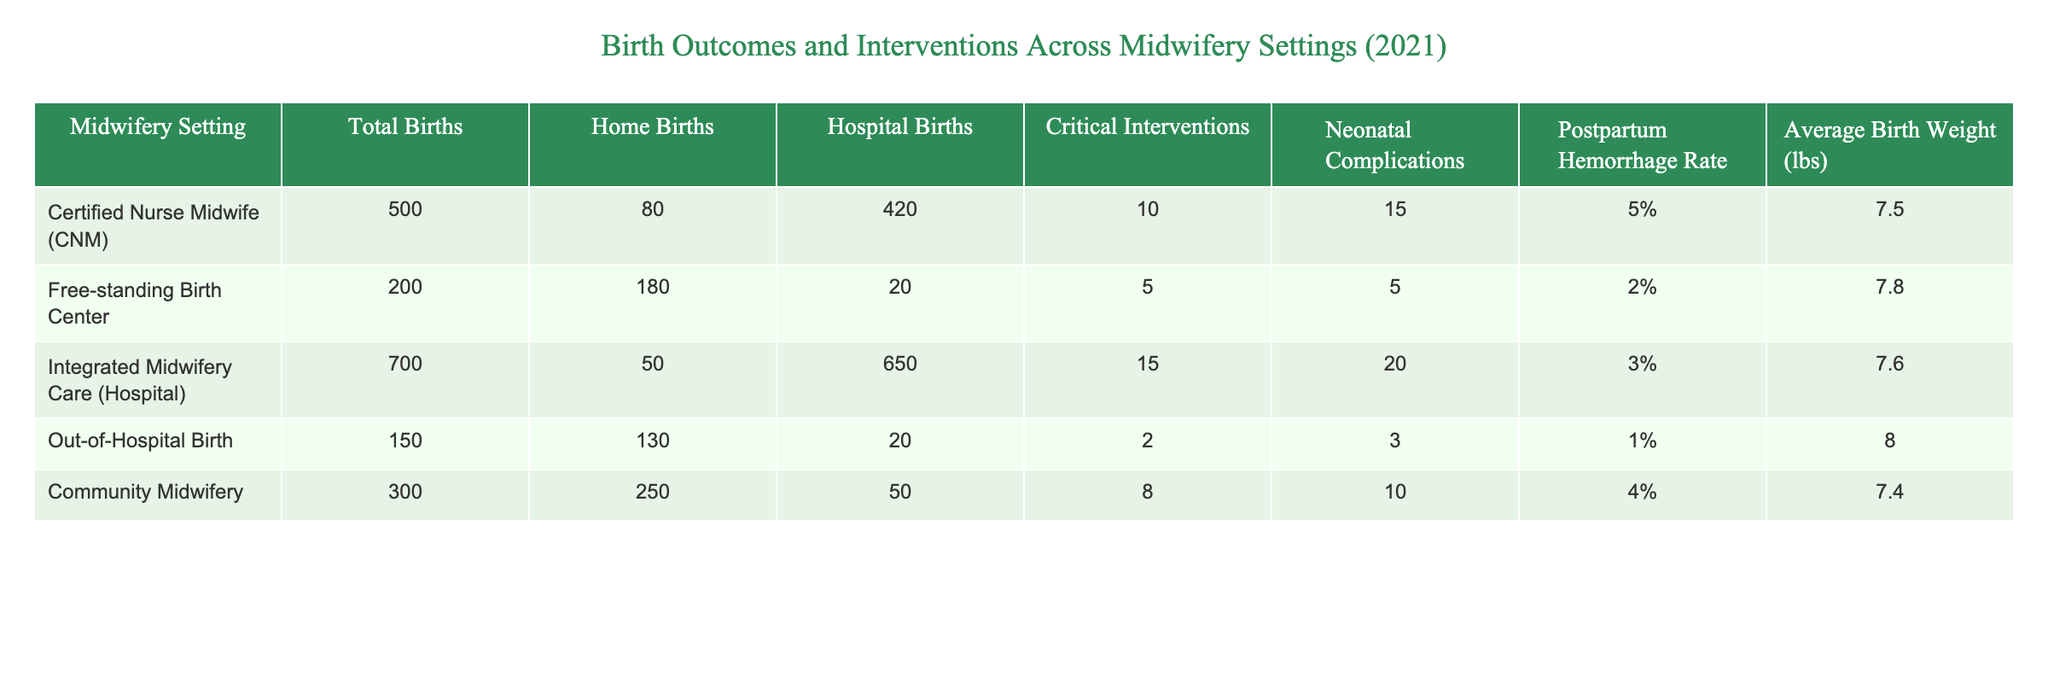What is the total number of births in the 'Free-standing Birth Center'? The value under the 'Total Births' column for 'Free-standing Birth Center' is directly listed as 200.
Answer: 200 What percentage of births in the 'Community Midwifery' setting involved postpartum hemorrhage? The 'Postpartum Hemorrhage Rate' for 'Community Midwifery' is presented as 4%, which can be read directly from the table.
Answer: 4% Which midwifery setting had the highest average birth weight? Comparing the 'Average Birth Weight (lbs)' across all settings, 'Out-of-Hospital Birth' has the highest value at 8.0 lbs.
Answer: 8.0 lbs How many births resulted in neonatal complications in the 'Integrated Midwifery Care (Hospital)'? The number of 'Neonatal Complications' for 'Integrated Midwifery Care (Hospital)' is shown as 20, which can be referred to directly from the table.
Answer: 20 What is the combined rate of critical interventions for 'Certified Nurse Midwife (CNM)' and 'Integrated Midwifery Care (Hospital)'? Adding the 'Critical Interventions' values: 10 (CNM) + 15 (Integrated Midwifery Care) = 25. Therefore, the combined rate is 25.
Answer: 25 In which setting did the lowest percentage of births have neonatal complications? Reviewing the 'Neonatal Complications' column, 'Free-standing Birth Center' has the lowest value at 5, compared to other settings. Thus, it has the lowest percentage.
Answer: Free-standing Birth Center Is the postpartum hemorrhage rate higher in 'Home Births' or 'Hospital Births'? From the table, 'Home Births' have a postpartum hemorrhage rate of 5%, while 'Hospital Births' have 3%. Thus, the rate is higher in 'Home Births'.
Answer: Yes What is the difference in total births between 'Out-of-Hospital Birth' and 'Certified Nurse Midwife (CNM)'? The total births for 'Out-of-Hospital Birth' is 150, while for 'CNM' it is 500. The difference is calculated as 500 - 150 = 350.
Answer: 350 What proportion of births in 'Free-standing Birth Center' are home births? Here, 'Free-standing Birth Center' has 180 home births out of a total of 200 births. Thus, the proportion is calculated as 180/200, which equals 0.9 or 90%.
Answer: 90% 